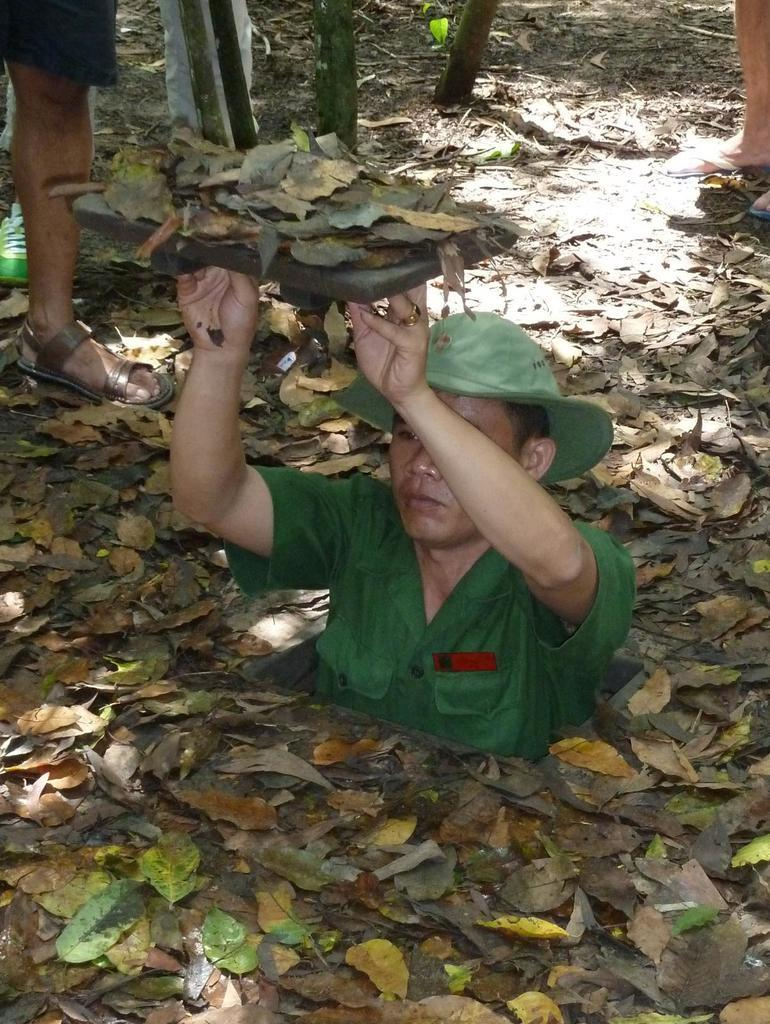How many people are in the image? There are people in the image, but the exact number is not specified. What is one person doing in the image? One person is holding an object in the image. What can be seen beneath the people in the image? The ground is visible in the image. What is present on the ground in the image? There are dried leaves and objects on the ground in the image. Can you see any boats in the harbor in the image? There is no harbor or boats present in the image. What type of material is used to cover the seashore in the image? There is no seashore or covering material present in the image. 